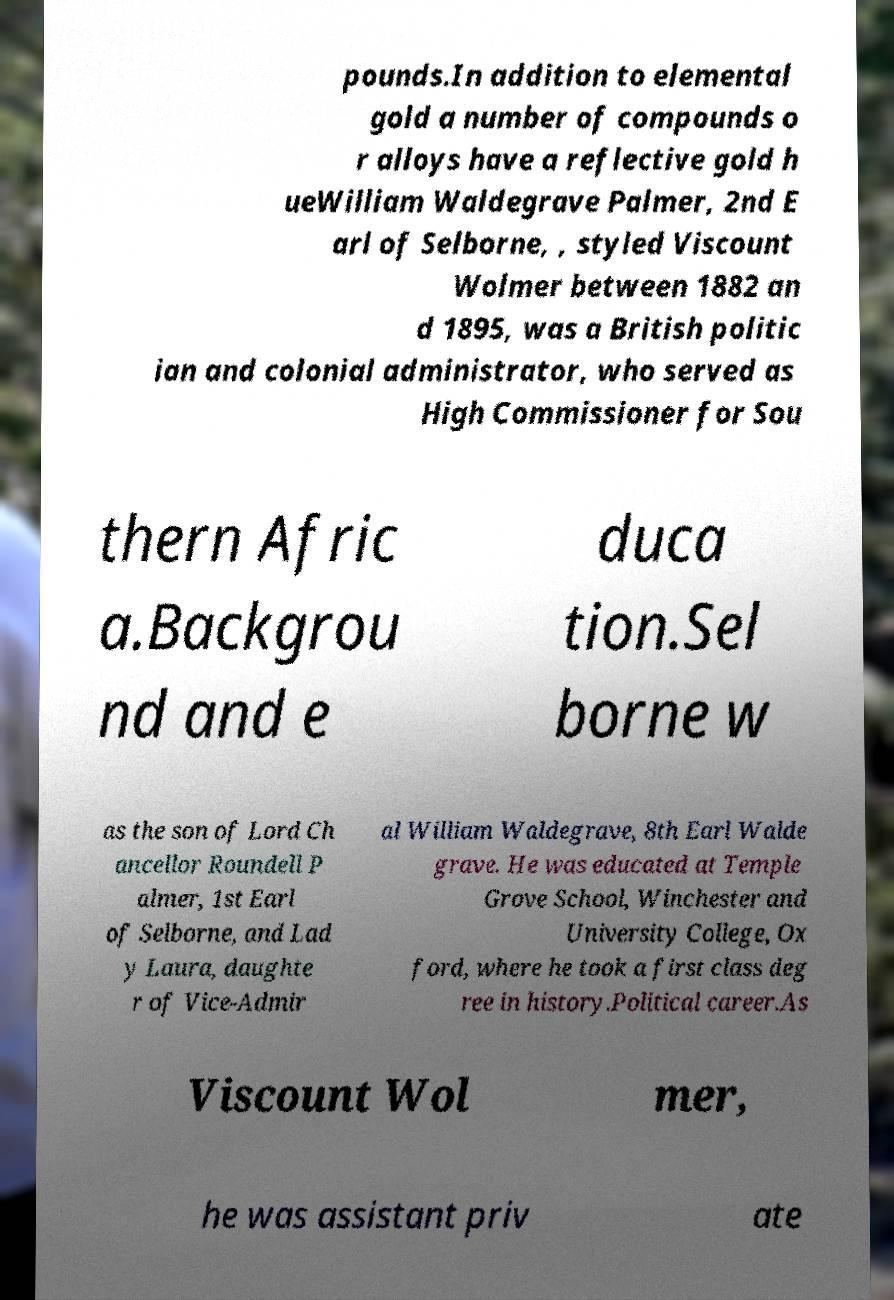Could you extract and type out the text from this image? pounds.In addition to elemental gold a number of compounds o r alloys have a reflective gold h ueWilliam Waldegrave Palmer, 2nd E arl of Selborne, , styled Viscount Wolmer between 1882 an d 1895, was a British politic ian and colonial administrator, who served as High Commissioner for Sou thern Afric a.Backgrou nd and e duca tion.Sel borne w as the son of Lord Ch ancellor Roundell P almer, 1st Earl of Selborne, and Lad y Laura, daughte r of Vice-Admir al William Waldegrave, 8th Earl Walde grave. He was educated at Temple Grove School, Winchester and University College, Ox ford, where he took a first class deg ree in history.Political career.As Viscount Wol mer, he was assistant priv ate 